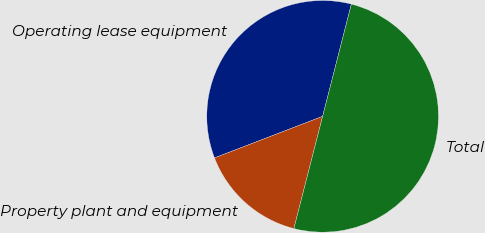<chart> <loc_0><loc_0><loc_500><loc_500><pie_chart><fcel>Operating lease equipment<fcel>Property plant and equipment<fcel>Total<nl><fcel>34.83%<fcel>15.17%<fcel>50.0%<nl></chart> 